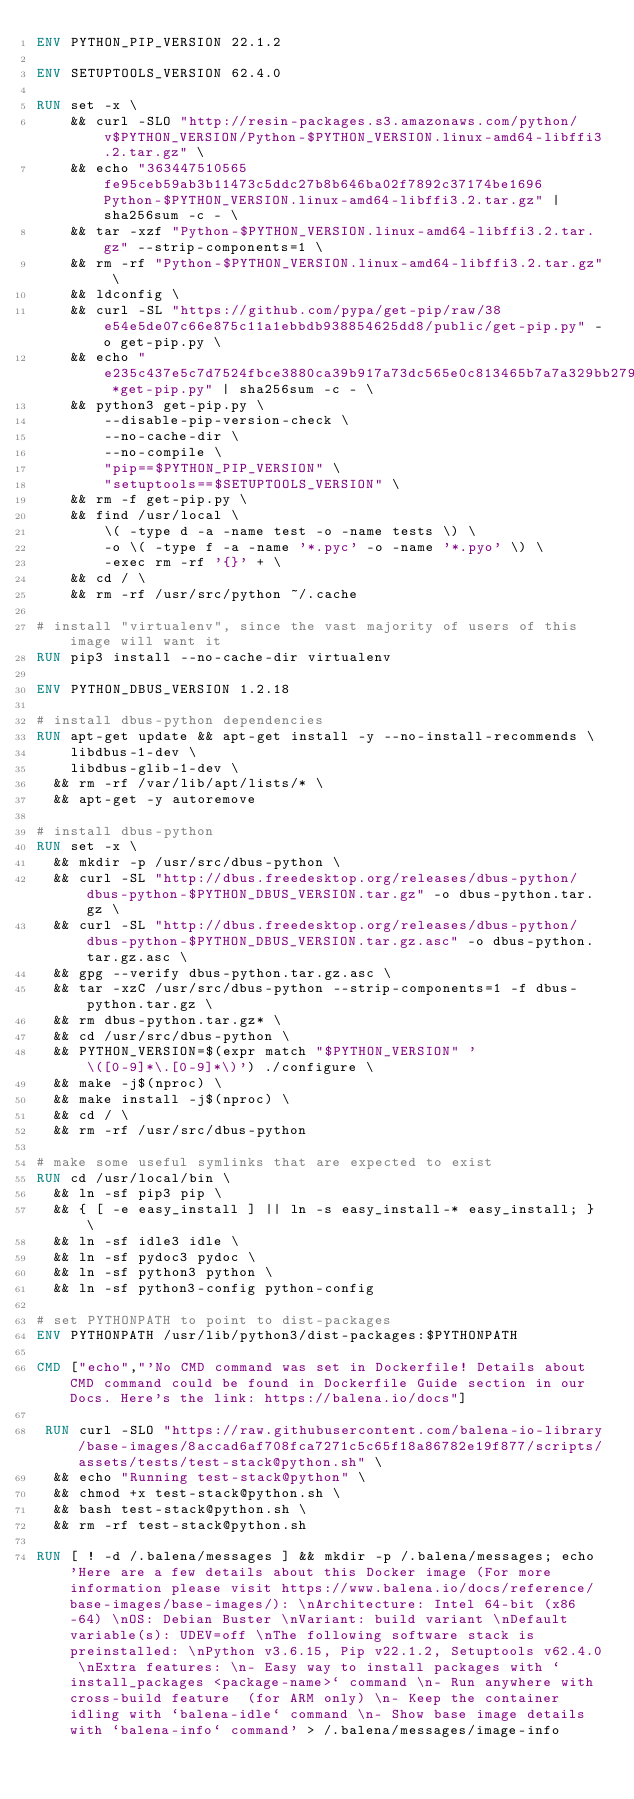Convert code to text. <code><loc_0><loc_0><loc_500><loc_500><_Dockerfile_>ENV PYTHON_PIP_VERSION 22.1.2

ENV SETUPTOOLS_VERSION 62.4.0

RUN set -x \
    && curl -SLO "http://resin-packages.s3.amazonaws.com/python/v$PYTHON_VERSION/Python-$PYTHON_VERSION.linux-amd64-libffi3.2.tar.gz" \
    && echo "363447510565fe95ceb59ab3b11473c5ddc27b8b646ba02f7892c37174be1696  Python-$PYTHON_VERSION.linux-amd64-libffi3.2.tar.gz" | sha256sum -c - \
    && tar -xzf "Python-$PYTHON_VERSION.linux-amd64-libffi3.2.tar.gz" --strip-components=1 \
    && rm -rf "Python-$PYTHON_VERSION.linux-amd64-libffi3.2.tar.gz" \
    && ldconfig \
    && curl -SL "https://github.com/pypa/get-pip/raw/38e54e5de07c66e875c11a1ebbdb938854625dd8/public/get-pip.py" -o get-pip.py \
    && echo "e235c437e5c7d7524fbce3880ca39b917a73dc565e0c813465b7a7a329bb279a *get-pip.py" | sha256sum -c - \
    && python3 get-pip.py \
        --disable-pip-version-check \
        --no-cache-dir \
        --no-compile \
        "pip==$PYTHON_PIP_VERSION" \
        "setuptools==$SETUPTOOLS_VERSION" \
    && rm -f get-pip.py \
    && find /usr/local \
        \( -type d -a -name test -o -name tests \) \
        -o \( -type f -a -name '*.pyc' -o -name '*.pyo' \) \
        -exec rm -rf '{}' + \
    && cd / \
    && rm -rf /usr/src/python ~/.cache

# install "virtualenv", since the vast majority of users of this image will want it
RUN pip3 install --no-cache-dir virtualenv

ENV PYTHON_DBUS_VERSION 1.2.18

# install dbus-python dependencies 
RUN apt-get update && apt-get install -y --no-install-recommends \
		libdbus-1-dev \
		libdbus-glib-1-dev \
	&& rm -rf /var/lib/apt/lists/* \
	&& apt-get -y autoremove

# install dbus-python
RUN set -x \
	&& mkdir -p /usr/src/dbus-python \
	&& curl -SL "http://dbus.freedesktop.org/releases/dbus-python/dbus-python-$PYTHON_DBUS_VERSION.tar.gz" -o dbus-python.tar.gz \
	&& curl -SL "http://dbus.freedesktop.org/releases/dbus-python/dbus-python-$PYTHON_DBUS_VERSION.tar.gz.asc" -o dbus-python.tar.gz.asc \
	&& gpg --verify dbus-python.tar.gz.asc \
	&& tar -xzC /usr/src/dbus-python --strip-components=1 -f dbus-python.tar.gz \
	&& rm dbus-python.tar.gz* \
	&& cd /usr/src/dbus-python \
	&& PYTHON_VERSION=$(expr match "$PYTHON_VERSION" '\([0-9]*\.[0-9]*\)') ./configure \
	&& make -j$(nproc) \
	&& make install -j$(nproc) \
	&& cd / \
	&& rm -rf /usr/src/dbus-python

# make some useful symlinks that are expected to exist
RUN cd /usr/local/bin \
	&& ln -sf pip3 pip \
	&& { [ -e easy_install ] || ln -s easy_install-* easy_install; } \
	&& ln -sf idle3 idle \
	&& ln -sf pydoc3 pydoc \
	&& ln -sf python3 python \
	&& ln -sf python3-config python-config

# set PYTHONPATH to point to dist-packages
ENV PYTHONPATH /usr/lib/python3/dist-packages:$PYTHONPATH

CMD ["echo","'No CMD command was set in Dockerfile! Details about CMD command could be found in Dockerfile Guide section in our Docs. Here's the link: https://balena.io/docs"]

 RUN curl -SLO "https://raw.githubusercontent.com/balena-io-library/base-images/8accad6af708fca7271c5c65f18a86782e19f877/scripts/assets/tests/test-stack@python.sh" \
  && echo "Running test-stack@python" \
  && chmod +x test-stack@python.sh \
  && bash test-stack@python.sh \
  && rm -rf test-stack@python.sh 

RUN [ ! -d /.balena/messages ] && mkdir -p /.balena/messages; echo 'Here are a few details about this Docker image (For more information please visit https://www.balena.io/docs/reference/base-images/base-images/): \nArchitecture: Intel 64-bit (x86-64) \nOS: Debian Buster \nVariant: build variant \nDefault variable(s): UDEV=off \nThe following software stack is preinstalled: \nPython v3.6.15, Pip v22.1.2, Setuptools v62.4.0 \nExtra features: \n- Easy way to install packages with `install_packages <package-name>` command \n- Run anywhere with cross-build feature  (for ARM only) \n- Keep the container idling with `balena-idle` command \n- Show base image details with `balena-info` command' > /.balena/messages/image-info</code> 